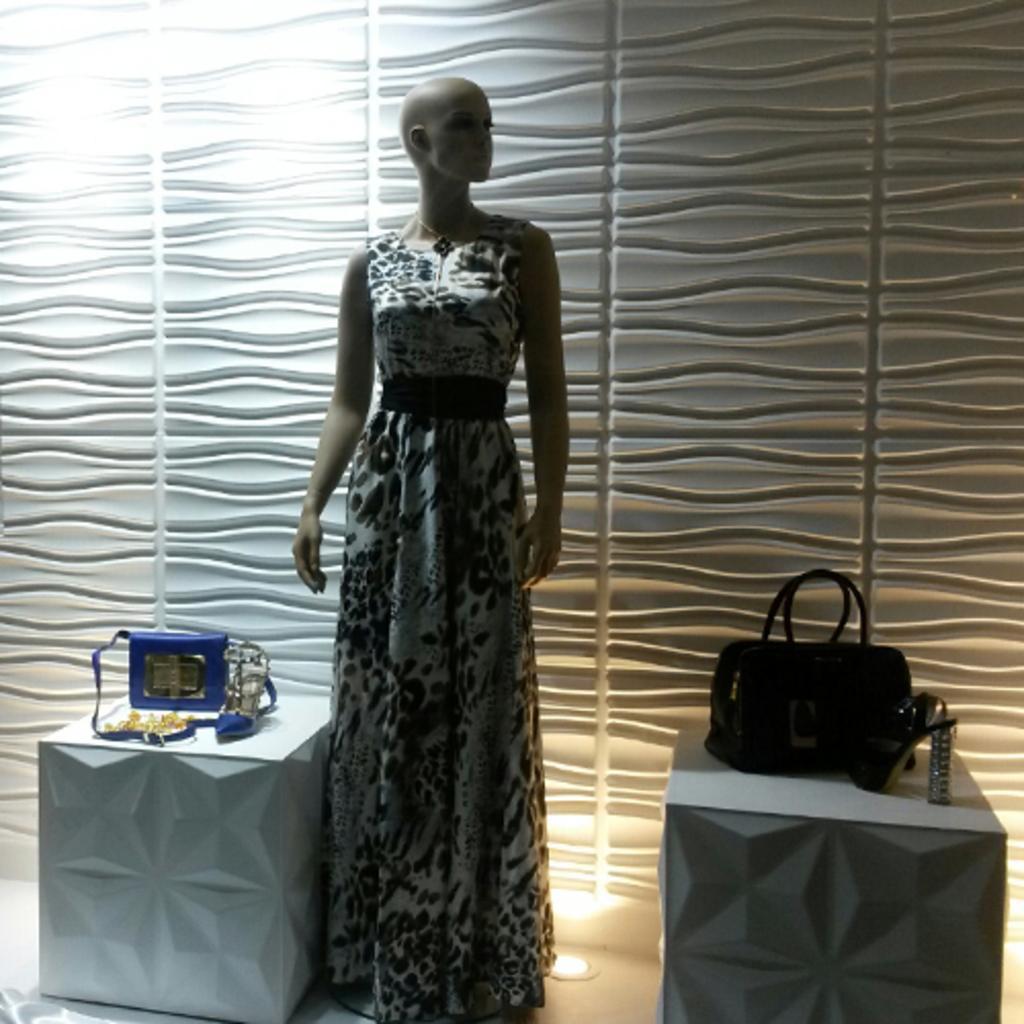In one or two sentences, can you explain what this image depicts? In this picture a lady mannequin is placed in the center of the image and with handbags placed on both the side of the mannequin. In the background there is a beautiful white curtain. 